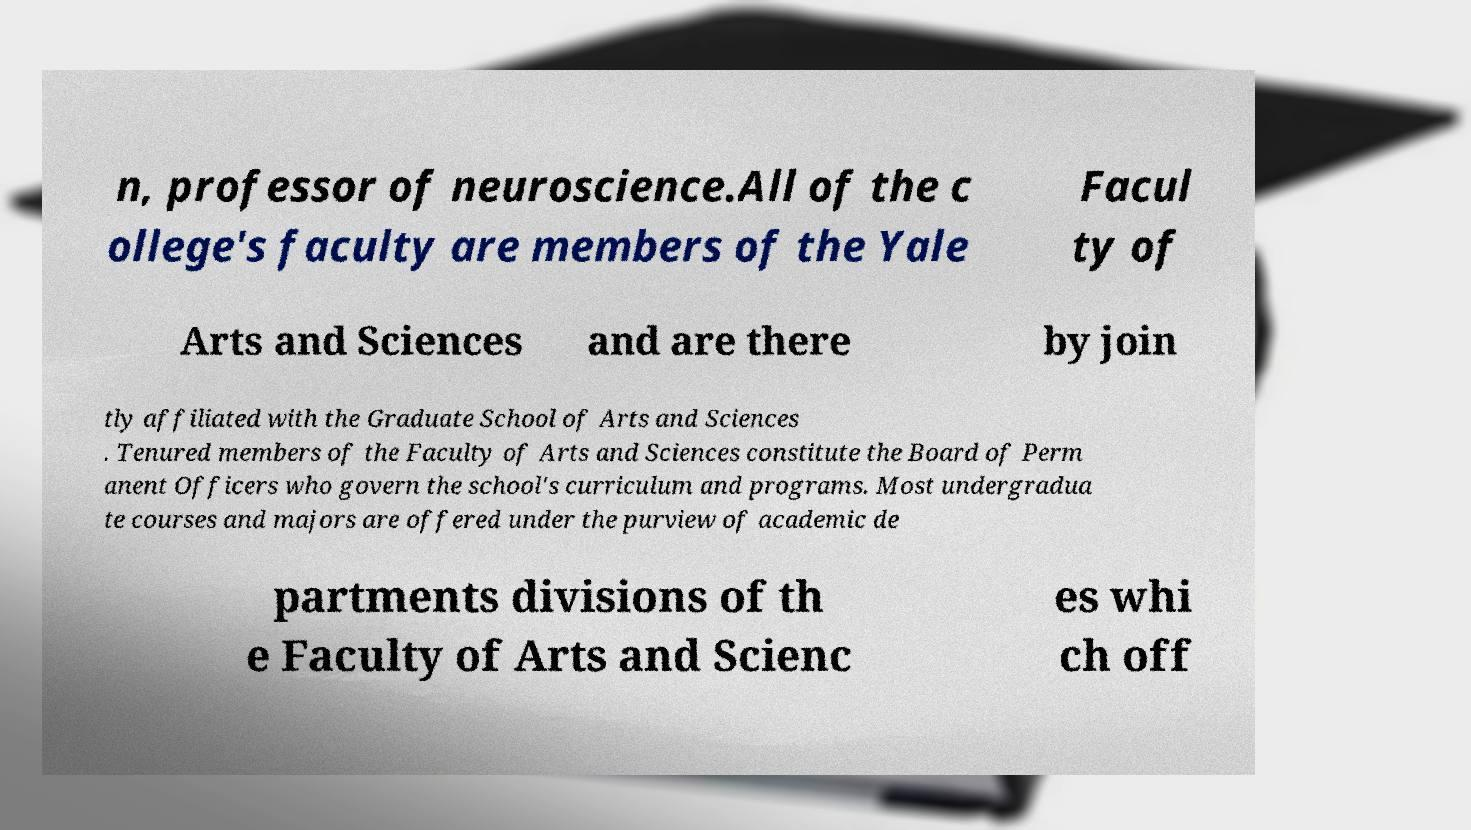Can you read and provide the text displayed in the image?This photo seems to have some interesting text. Can you extract and type it out for me? n, professor of neuroscience.All of the c ollege's faculty are members of the Yale Facul ty of Arts and Sciences and are there by join tly affiliated with the Graduate School of Arts and Sciences . Tenured members of the Faculty of Arts and Sciences constitute the Board of Perm anent Officers who govern the school's curriculum and programs. Most undergradua te courses and majors are offered under the purview of academic de partments divisions of th e Faculty of Arts and Scienc es whi ch off 